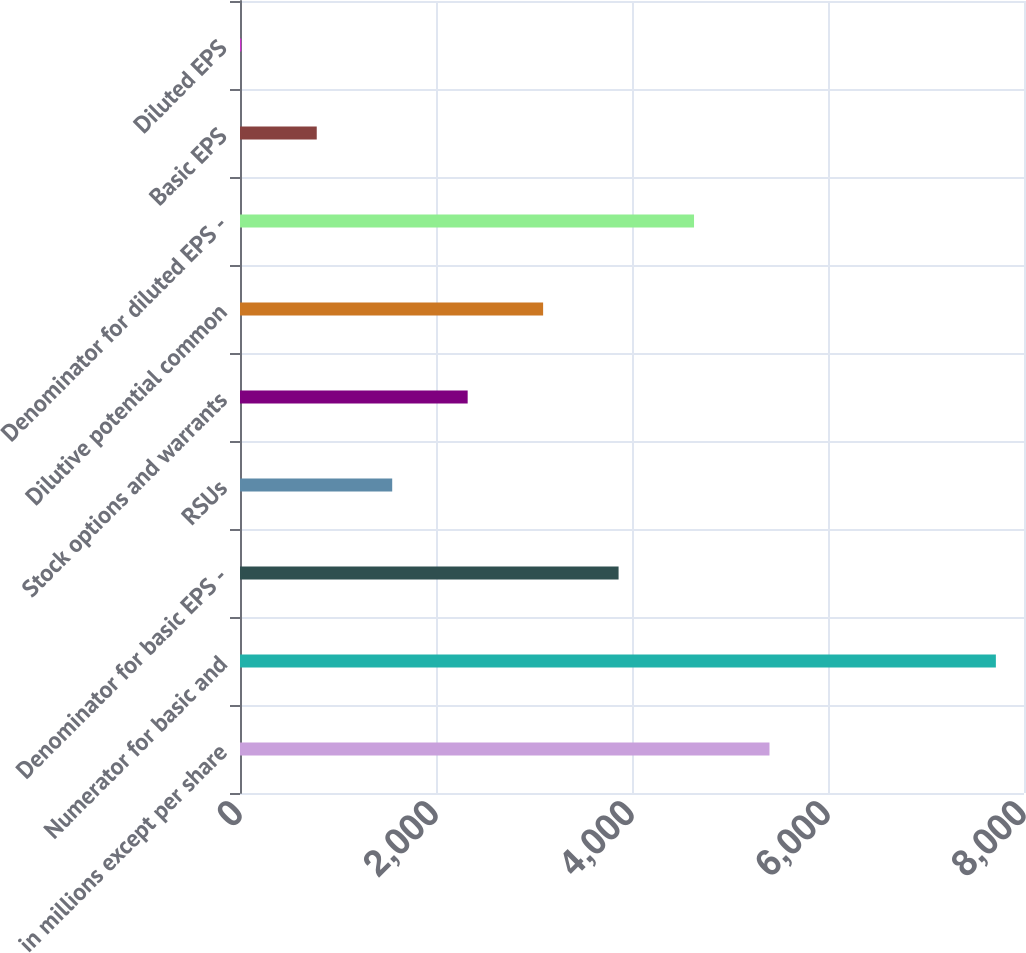Convert chart. <chart><loc_0><loc_0><loc_500><loc_500><bar_chart><fcel>in millions except per share<fcel>Numerator for basic and<fcel>Denominator for basic EPS -<fcel>RSUs<fcel>Stock options and warrants<fcel>Dilutive potential common<fcel>Denominator for diluted EPS -<fcel>Basic EPS<fcel>Diluted EPS<nl><fcel>5403.04<fcel>7713<fcel>3863.08<fcel>1553.14<fcel>2323.12<fcel>3093.1<fcel>4633.06<fcel>783.16<fcel>13.18<nl></chart> 